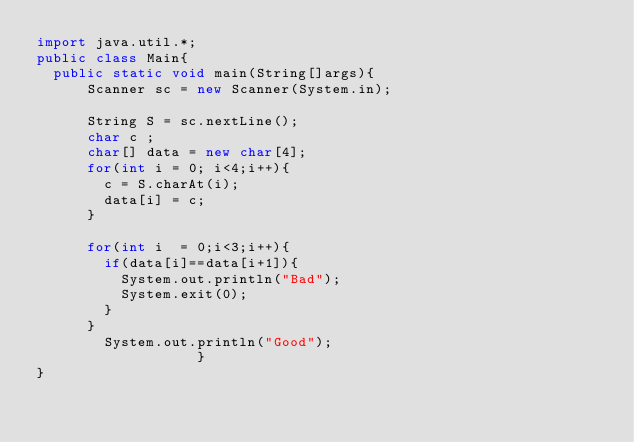Convert code to text. <code><loc_0><loc_0><loc_500><loc_500><_Java_>import java.util.*;
public class Main{
  public static void main(String[]args){
      Scanner sc = new Scanner(System.in);

      String S = sc.nextLine();
      char c ;
      char[] data = new char[4];
      for(int i = 0; i<4;i++){
        c = S.charAt(i);
        data[i] = c;
      }

      for(int i  = 0;i<3;i++){
        if(data[i]==data[i+1]){
          System.out.println("Bad");
          System.exit(0);
        }
      }
        System.out.println("Good");
                   }
}
</code> 